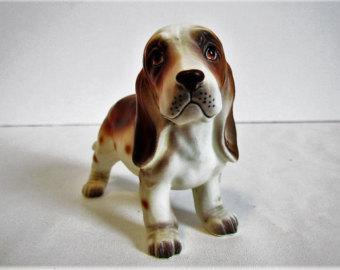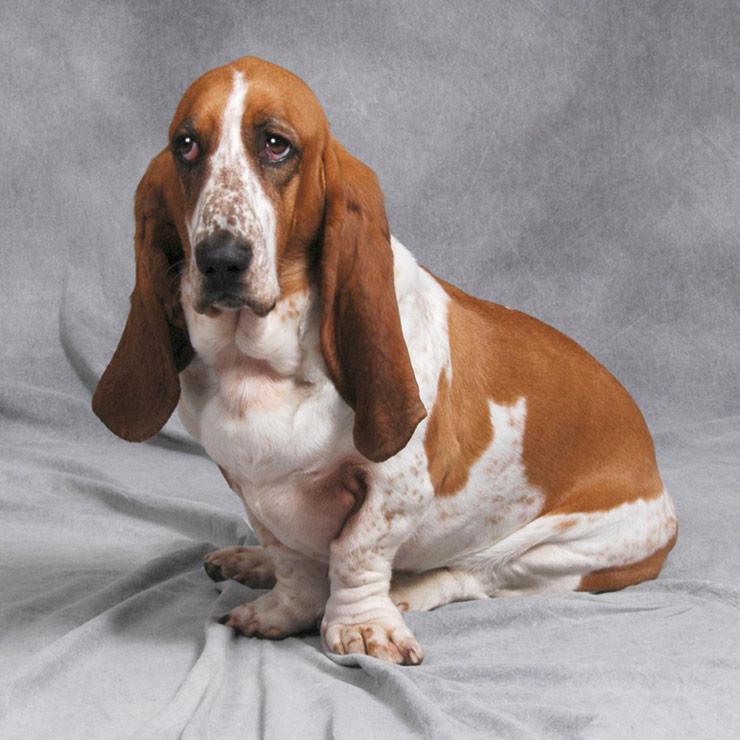The first image is the image on the left, the second image is the image on the right. Analyze the images presented: Is the assertion "An image shows one basset hound, which is looking up and toward the right." valid? Answer yes or no. No. 